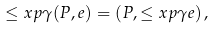Convert formula to latex. <formula><loc_0><loc_0><loc_500><loc_500>\leq x p { \gamma } { ( P , e ) } = ( P , \leq x p { \gamma } { e } ) \, ,</formula> 